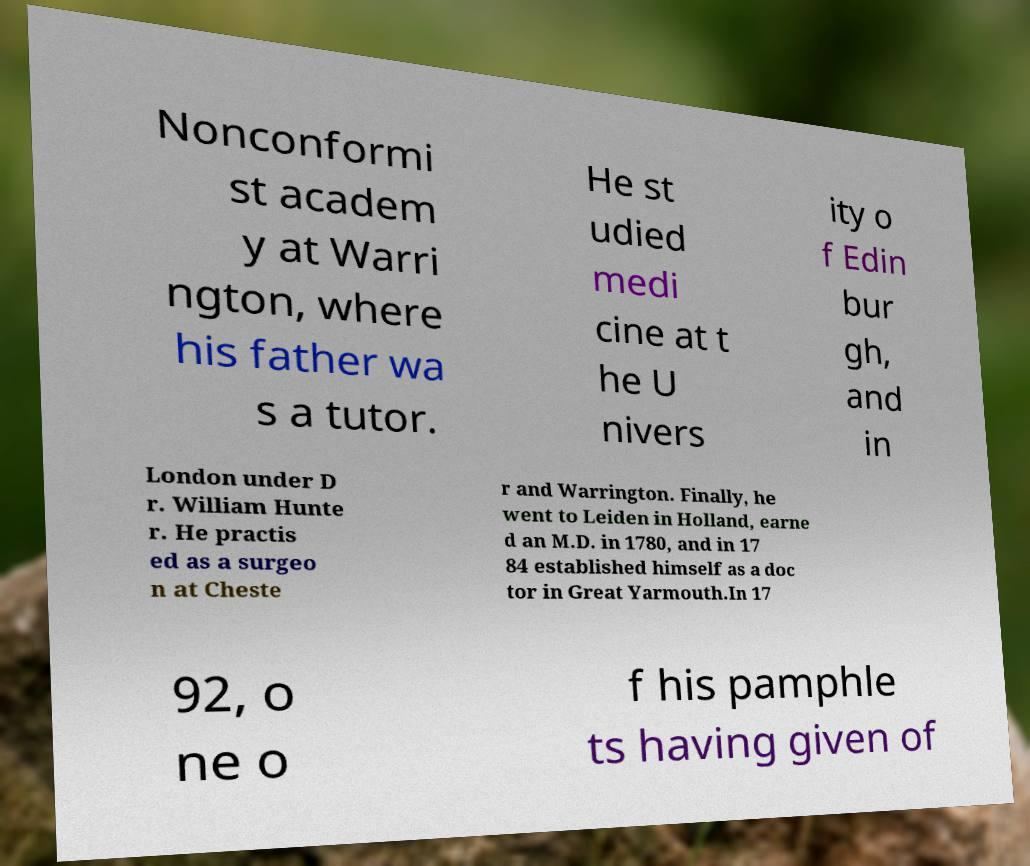Please identify and transcribe the text found in this image. Nonconformi st academ y at Warri ngton, where his father wa s a tutor. He st udied medi cine at t he U nivers ity o f Edin bur gh, and in London under D r. William Hunte r. He practis ed as a surgeo n at Cheste r and Warrington. Finally, he went to Leiden in Holland, earne d an M.D. in 1780, and in 17 84 established himself as a doc tor in Great Yarmouth.In 17 92, o ne o f his pamphle ts having given of 